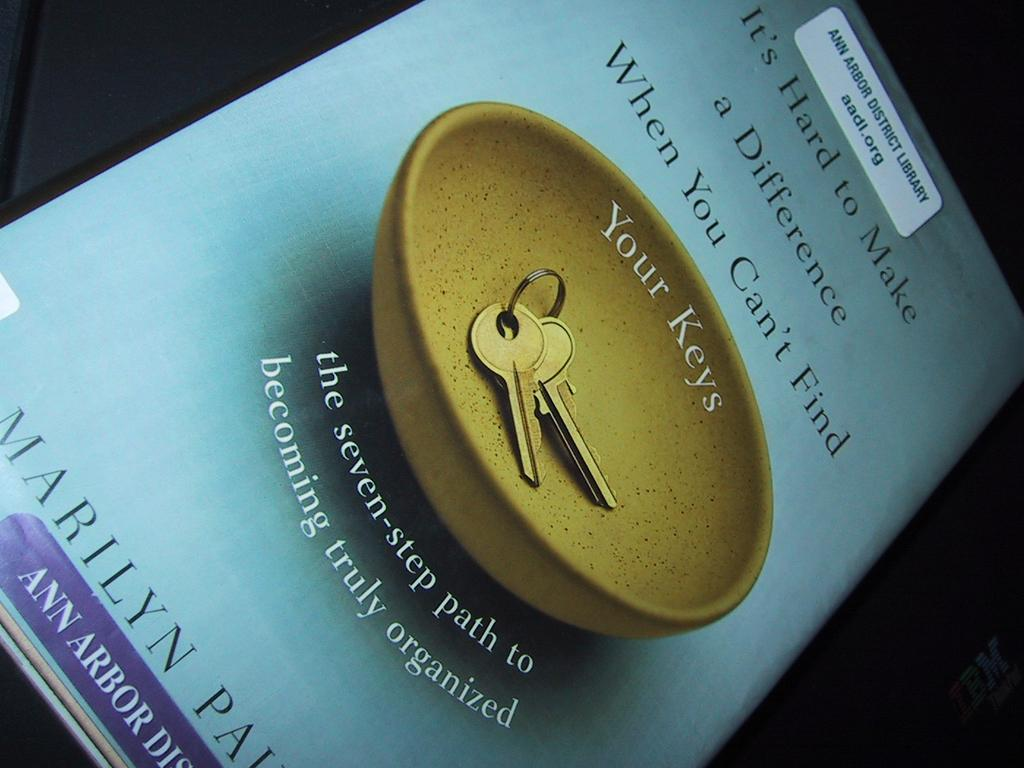<image>
Offer a succinct explanation of the picture presented. A book from the library about how to become organized. 